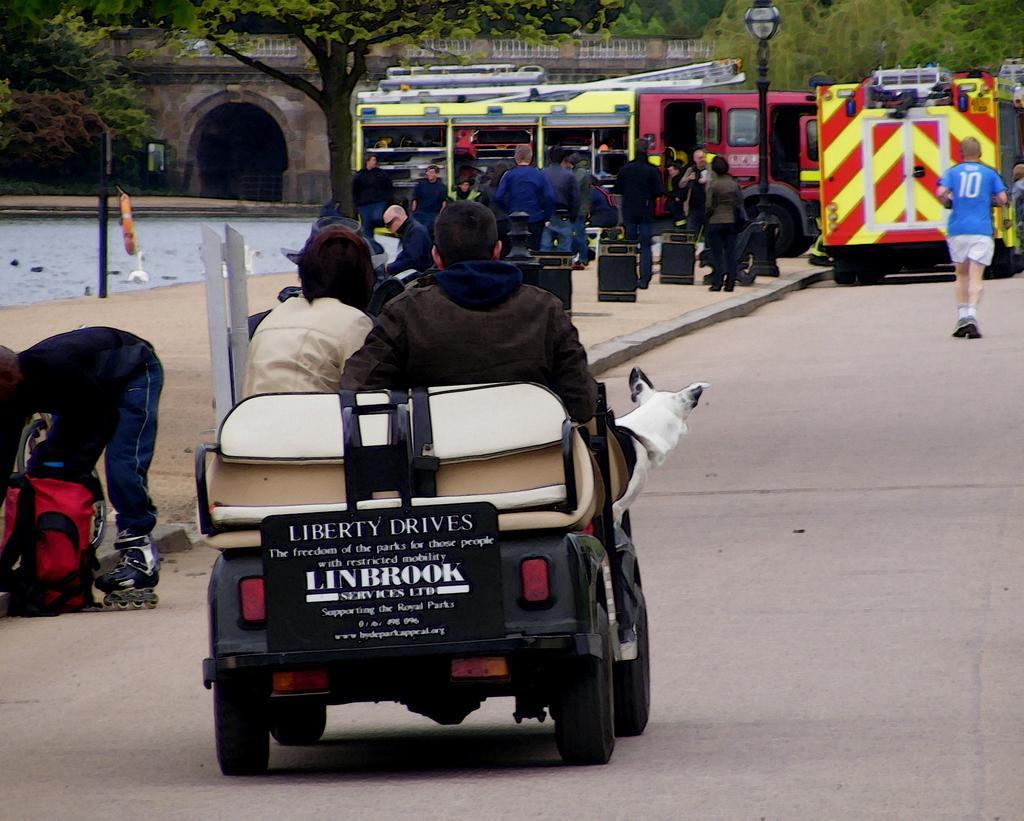How would you summarize this image in a sentence or two? In this picture I can see few people are riding vehicles on the road and also few people are on the road, side we can see people sitting near vehicle and there are some trees, water and bridge. 